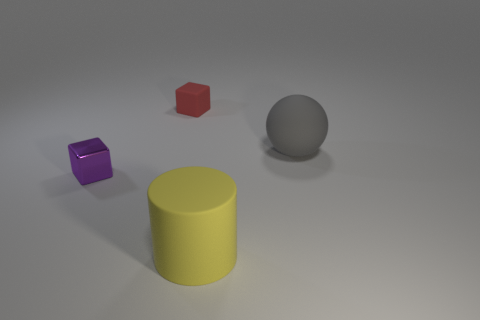What number of large objects have the same color as the small shiny cube?
Your answer should be very brief. 0. Are there any metal objects in front of the tiny purple metallic object?
Your response must be concise. No. There is a small red matte object; is its shape the same as the tiny object in front of the gray rubber ball?
Offer a very short reply. Yes. What number of objects are either objects on the right side of the shiny cube or large gray matte spheres?
Offer a very short reply. 3. Are there any other things that are the same material as the purple block?
Provide a short and direct response. No. How many matte things are behind the cylinder and left of the big gray rubber ball?
Your answer should be compact. 1. How many objects are objects behind the gray object or yellow objects to the right of the tiny purple metal thing?
Your answer should be compact. 2. How many other things are there of the same shape as the large yellow matte object?
Your answer should be compact. 0. How many other objects are there of the same size as the yellow matte cylinder?
Provide a short and direct response. 1. Is the material of the gray thing the same as the small purple object?
Ensure brevity in your answer.  No. 